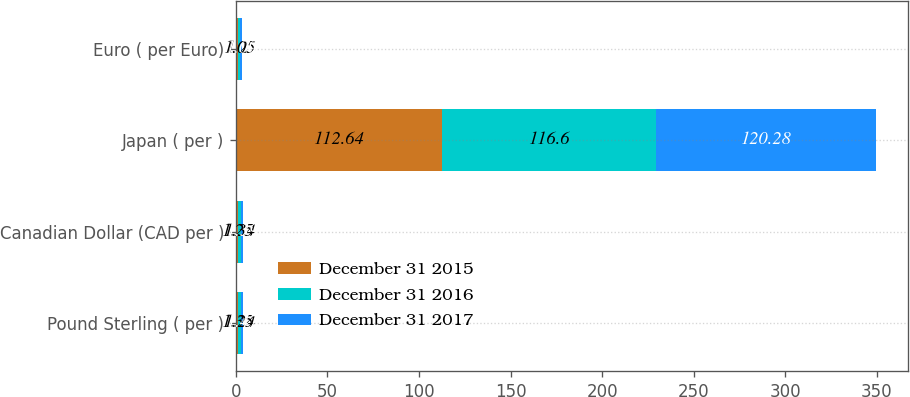Convert chart. <chart><loc_0><loc_0><loc_500><loc_500><stacked_bar_chart><ecel><fcel>Pound Sterling ( per )<fcel>Canadian Dollar (CAD per )<fcel>Japan ( per )<fcel>Euro ( per Euro)<nl><fcel>December 31 2015<fcel>1.35<fcel>1.25<fcel>112.64<fcel>1.2<nl><fcel>December 31 2016<fcel>1.24<fcel>1.34<fcel>116.6<fcel>1.05<nl><fcel>December 31 2017<fcel>1.47<fcel>1.39<fcel>120.28<fcel>1.09<nl></chart> 